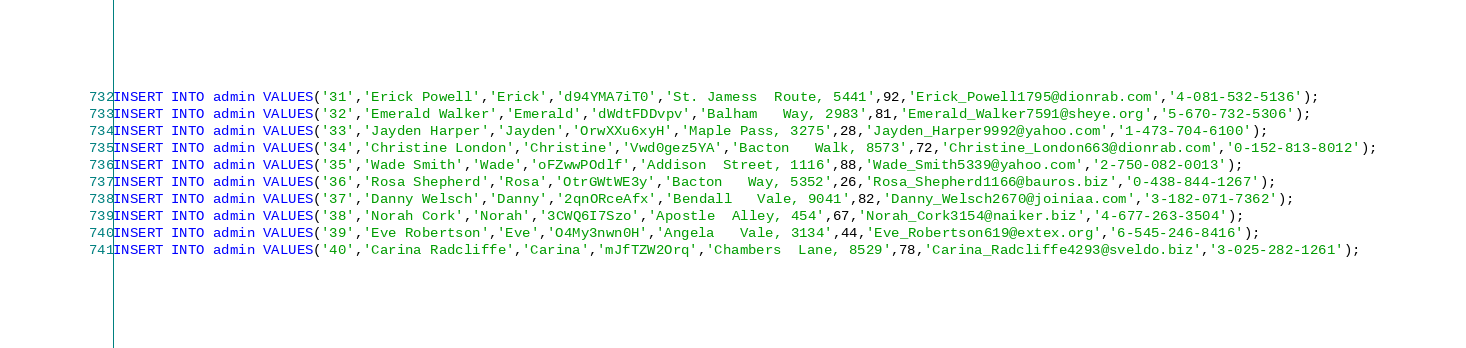<code> <loc_0><loc_0><loc_500><loc_500><_SQL_>INSERT INTO admin VALUES('31','Erick Powell','Erick','d94YMA7iT0','St. Jamess  Route, 5441',92,'Erick_Powell1795@dionrab.com','4-081-532-5136');
INSERT INTO admin VALUES('32','Emerald Walker','Emerald','dWdtFDDvpv','Balham   Way, 2983',81,'Emerald_Walker7591@sheye.org','5-670-732-5306');
INSERT INTO admin VALUES('33','Jayden Harper','Jayden','OrwXXu6xyH','Maple Pass, 3275',28,'Jayden_Harper9992@yahoo.com','1-473-704-6100');
INSERT INTO admin VALUES('34','Christine London','Christine','Vwd0gez5YA','Bacton   Walk, 8573',72,'Christine_London663@dionrab.com','0-152-813-8012');
INSERT INTO admin VALUES('35','Wade Smith','Wade','oFZwwPOdlf','Addison  Street, 1116',88,'Wade_Smith5339@yahoo.com','2-750-082-0013');
INSERT INTO admin VALUES('36','Rosa Shepherd','Rosa','OtrGWtWE3y','Bacton   Way, 5352',26,'Rosa_Shepherd1166@bauros.biz','0-438-844-1267');
INSERT INTO admin VALUES('37','Danny Welsch','Danny','2qnORceAfx','Bendall   Vale, 9041',82,'Danny_Welsch2670@joiniaa.com','3-182-071-7362');
INSERT INTO admin VALUES('38','Norah Cork','Norah','3CWQ6I7Szo','Apostle  Alley, 454',67,'Norah_Cork3154@naiker.biz','4-677-263-3504');
INSERT INTO admin VALUES('39','Eve Robertson','Eve','O4My3nwn0H','Angela   Vale, 3134',44,'Eve_Robertson619@extex.org','6-545-246-8416');
INSERT INTO admin VALUES('40','Carina Radcliffe','Carina','mJfTZW2Orq','Chambers  Lane, 8529',78,'Carina_Radcliffe4293@sveldo.biz','3-025-282-1261');

</code> 